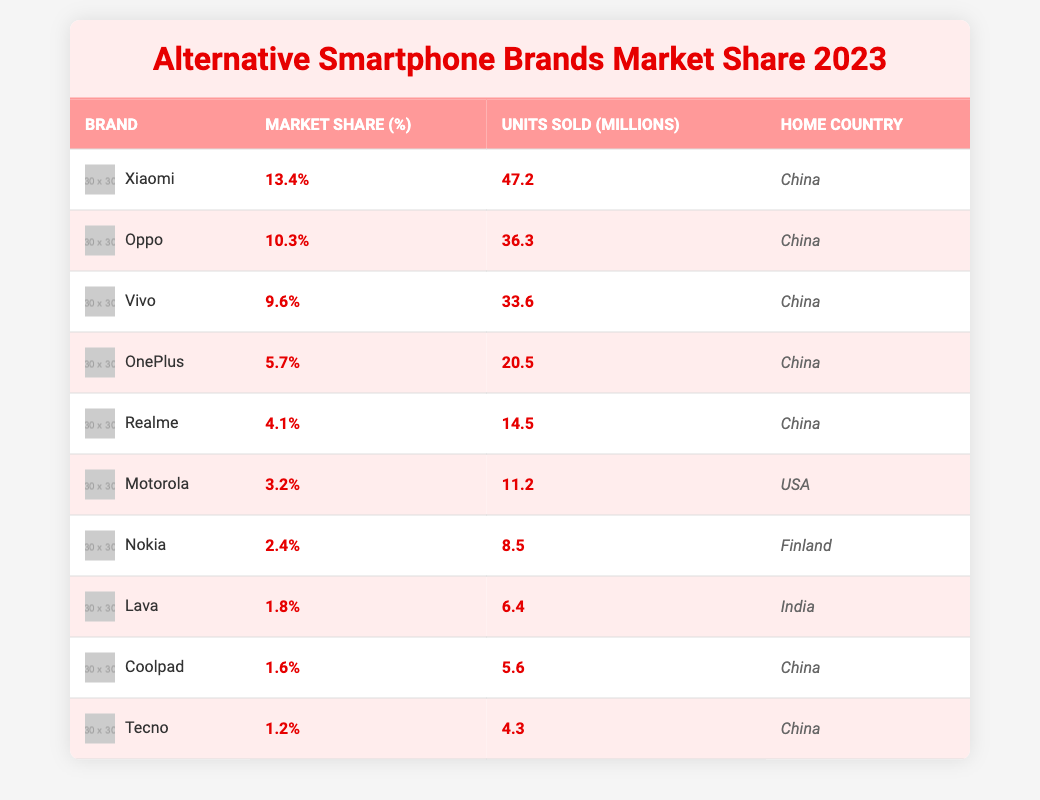What is the market share percentage of Xiaomi? By looking at the table, the market share percentage listed for Xiaomi is clearly noted in its row. It is displayed under the "Market Share (%)" column.
Answer: 13.4% Which brand has the highest market share in 2023? The table lists the market shares of various brands, and by comparing the values in the "Market Share (%)" column, we find that Xiaomi, with 13.4%, has the highest market share.
Answer: Xiaomi Which brand sold fewer than 5 million units? By examining the "Units Sold (millions)" column, we can identify the brands that sold below 5 million. We see that Tecno (4.3 million) and Coolpad (5.6 million) do not fall below this threshold, while others in the table sold more.
Answer: Tecno What is the total market share percentage of all listed brands? We sum the market share percentages of all brands by adding each value in the "Market Share (%)" column. The computation would yield: 13.4 + 10.3 + 9.6 + 5.7 + 4.1 + 3.2 + 2.4 + 1.8 + 1.6 + 1.2 = 53.3%.
Answer: 53.3% Is the home country of Motorola listed as China? Looking at the "Home Country" column, we can confirm that the entry for Motorola specifies the USA as its home country, not China.
Answer: No How many brands have a market share percentage greater than 5%? By reviewing the "Market Share (%)" column, we count the brands with percentages above 5%: Xiaomi (13.4%), Oppo (10.3%), Vivo (9.6%), and OnePlus (5.7%). This totals to four brands.
Answer: 4 brands Which brand sold the most units and how many? The "Units Sold (millions)" column indicates that Xiaomi sold the most units, with a total of 47.2 million units sold.
Answer: Xiaomi, 47.2 million What is the average units sold for brands with a market share less than 3%? We first identify the brands with less than 3% market share: Motorola (11.2 million), Nokia (8.5 million), Lava (6.4 million), Coolpad (5.6 million), and Tecno (4.3 million). Their total is calculated as 11.2 + 8.5 + 6.4 + 5.6 + 4.3 = 36.4 million, and since there are 5 brands, the average is 36.4 / 5 = 7.28 million.
Answer: 7.28 million Are all the top three brands home to China? By checking the rows for the top three brands (Xiaomi, Oppo, Vivo) in the table, we see that all three brands indeed list China as their home country.
Answer: Yes What is the difference in units sold between the top and the bottom brand? Taking the units sold for the top brand, Xiaomi (47.2 million), and the bottom brand, Tecno (4.3 million), we calculate the difference: 47.2 - 4.3 = 42.9 million units.
Answer: 42.9 million 